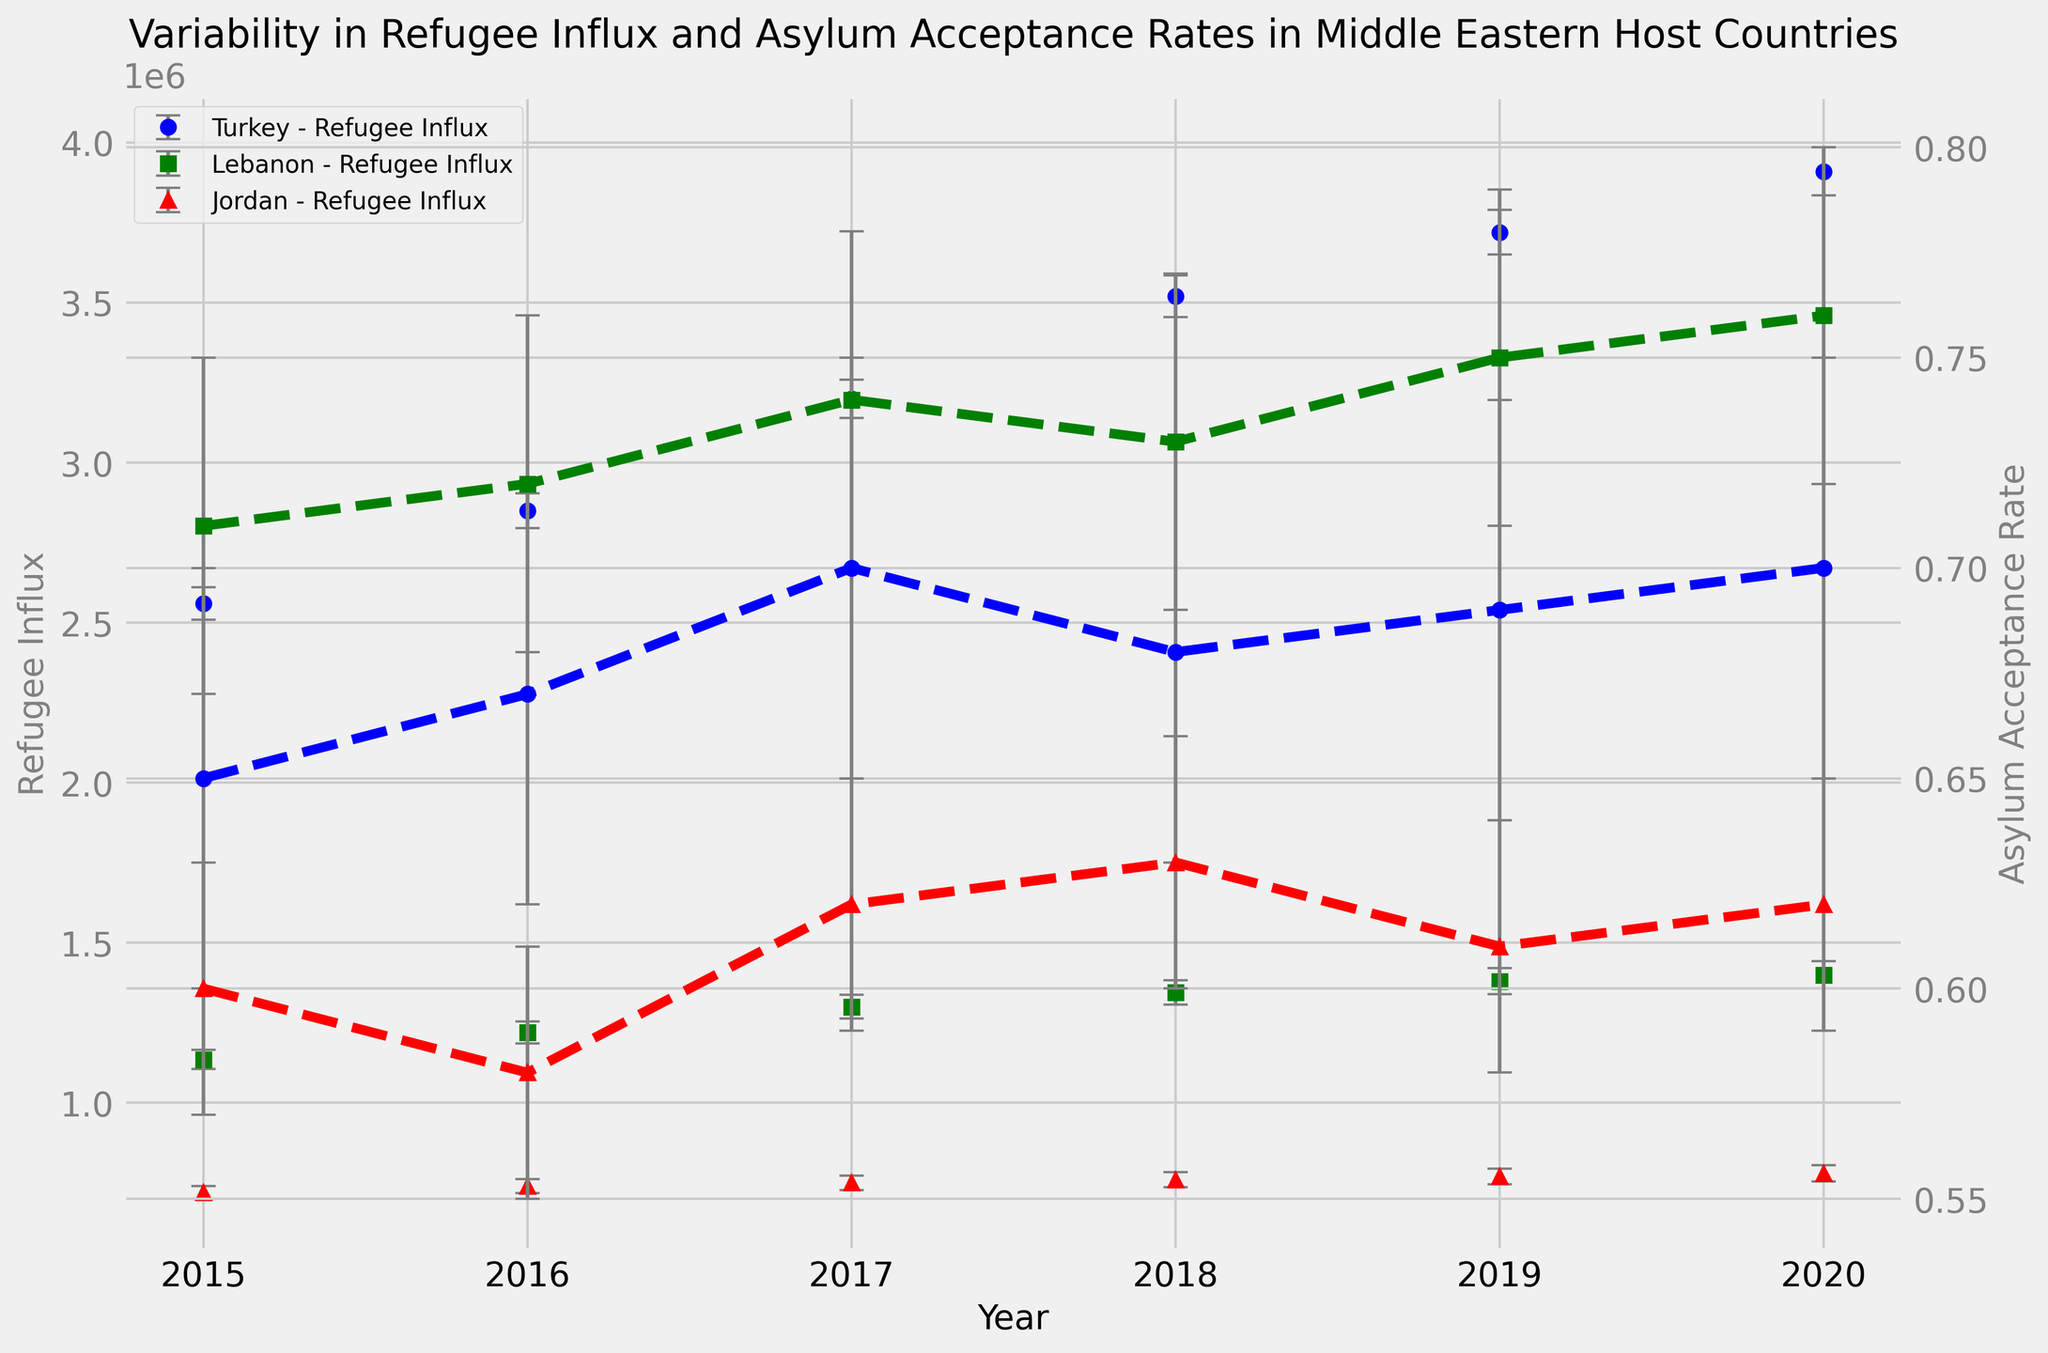Which country had the highest refugee influx in 2018? To determine the country with the highest refugee influx in 2018, look at the points representing 2018 on the x-axis and check the y-values for refugee influx across the countries. Turkey had approximately 3.52 million, Lebanon had approximately 1.345 million, and Jordan had approximately 0.76 million. Turkey had the highest refugee influx.
Answer: Turkey What is the average asylum acceptance rate of Lebanon over the years 2015 to 2020? The average is found by summing up the acceptance rates for each year and dividing by the number of years. For Lebanon, the rates are 0.71, 0.72, 0.74, 0.73, 0.75, and 0.76. Sum these to get (0.71 + 0.72 + 0.74 + 0.73 + 0.75 + 0.76) = 4.41, and then divide by 6.
Answer: 0.735 Which country had the largest increase in refugee influx from 2015 to 2020? To find the country with the largest increase, subtract the 2015 refugee influx from the 2020 refugee influx for each country. Turkey went from 2,560,000 to 3,910,000 (an increase of 1,350,000), Lebanon from 1,135,000 to 1,400,000 (an increase of 265,000), and Jordan from 720,000 to 780,000 (an increase of 60,000). Turkey had the largest increase.
Answer: Turkey How does the asylum acceptance rate trend for Jordan compare with that of Lebanon from 2015 to 2020? Examine the trend lines (dashed) for Jordan and Lebanon. Lebanon's asylum acceptance rate shows a generally increasing trend from 0.71 to 0.76. Jordan's rate fluctuates but does not show a clear increasing or decreasing trend, starting at 0.60 in 2015 and oscillating around that value. Lebanon has a consistently increasing trend, while Jordan's trend is more variable.
Answer: Lebanon's rate increases, Jordan's is variable What year did Turkey reach its highest asylum acceptance rate, and what was it? Look for the peak of the dashed line representing Turkey's asylum acceptance rate. Turkey's highest rate was in 2017 and 2020, both years showing a rate of 0.70.
Answer: 2017 and 2020, 0.70 Compare Lebanon and Jordan's refugee influx in 2019. Which country had more refugees, and by how much? Check the refugee influx for each country in 2019. Lebanon had 1,380,000 refugees, and Jordan had 770,000. Subtract Jordan's number from Lebanon's: 1,380,000 - 770,000. Lebanon had 610,000 more refugees than Jordan.
Answer: Lebanon, 610,000 Which country's asylum acceptance rate in 2016 had the smallest error margin? Compare the error margins for asylum acceptance rates in 2016. Turkey and Jordan both have an error margin of 0.05, while Lebanon has the smallest error margin of 0.04.
Answer: Lebanon What is the total refugee influx in the region in 2020? Sum the refugee influx for Turkey, Lebanon, and Jordan in 2020. Turkey: 3,910,000, Lebanon: 1,400,000, Jordan: 780,000. Total = 3,910,000 + 1,400,000 + 780,000.
Answer: 6,090,000 Which country had the most stable (least variable) asylum acceptance rate over the years shown? Examine the error bars for asylum acceptance rates across the countries. The smallest error bars indicate the least variability. Jordan has consistently smaller error bars compared to Turkey and Lebanon, indicating more stability in its acceptance rate.
Answer: Jordan What is the difference in refugee influx between Lebanon and Turkey in 2017? Determine the refugee influx for Lebanon and Turkey in 2017. Turkey had 3,200,000 refugees, and Lebanon had 1,300,000. Subtract Lebanon's value from Turkey's: 3,200,000 - 1,300,000.
Answer: 1,900,000 